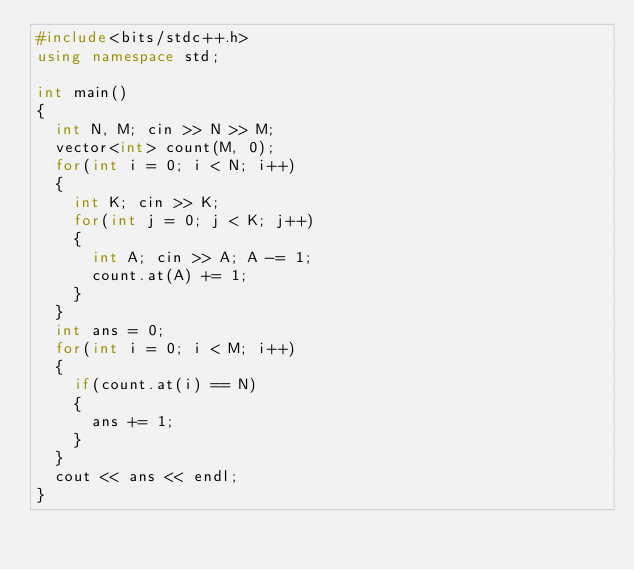<code> <loc_0><loc_0><loc_500><loc_500><_C++_>#include<bits/stdc++.h>
using namespace std;

int main()
{
  int N, M; cin >> N >> M;
  vector<int> count(M, 0);
  for(int i = 0; i < N; i++)
  {
    int K; cin >> K;
    for(int j = 0; j < K; j++)
    {
      int A; cin >> A; A -= 1;
      count.at(A) += 1;
    }
  }
  int ans = 0;
  for(int i = 0; i < M; i++)
  {
    if(count.at(i) == N)
    {
      ans += 1;
    }
  }
  cout << ans << endl;
}</code> 